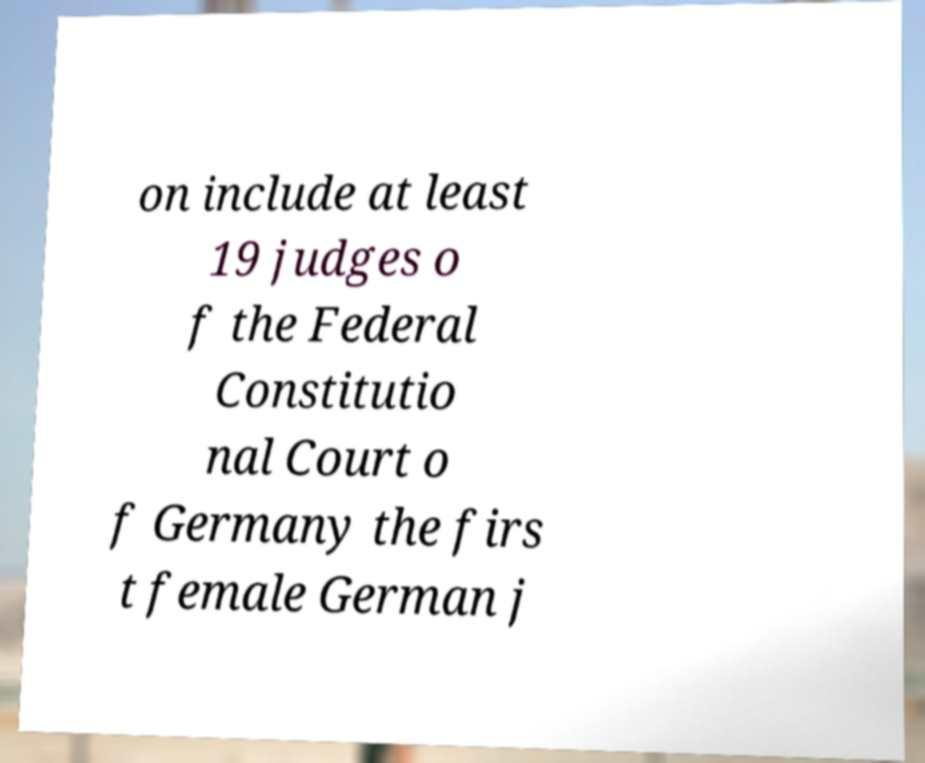Can you accurately transcribe the text from the provided image for me? on include at least 19 judges o f the Federal Constitutio nal Court o f Germany the firs t female German j 